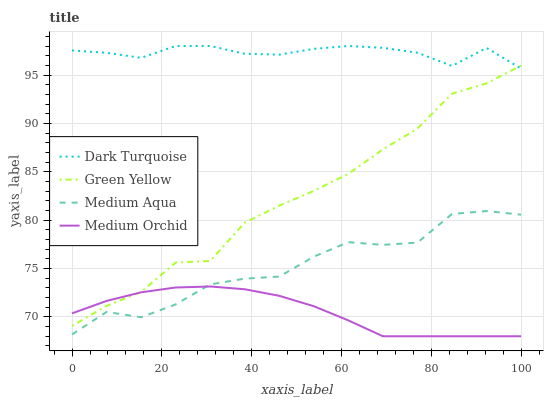Does Medium Orchid have the minimum area under the curve?
Answer yes or no. Yes. Does Dark Turquoise have the maximum area under the curve?
Answer yes or no. Yes. Does Green Yellow have the minimum area under the curve?
Answer yes or no. No. Does Green Yellow have the maximum area under the curve?
Answer yes or no. No. Is Medium Orchid the smoothest?
Answer yes or no. Yes. Is Medium Aqua the roughest?
Answer yes or no. Yes. Is Green Yellow the smoothest?
Answer yes or no. No. Is Green Yellow the roughest?
Answer yes or no. No. Does Medium Orchid have the lowest value?
Answer yes or no. Yes. Does Green Yellow have the lowest value?
Answer yes or no. No. Does Dark Turquoise have the highest value?
Answer yes or no. Yes. Does Green Yellow have the highest value?
Answer yes or no. No. Is Medium Orchid less than Dark Turquoise?
Answer yes or no. Yes. Is Green Yellow greater than Medium Aqua?
Answer yes or no. Yes. Does Green Yellow intersect Dark Turquoise?
Answer yes or no. Yes. Is Green Yellow less than Dark Turquoise?
Answer yes or no. No. Is Green Yellow greater than Dark Turquoise?
Answer yes or no. No. Does Medium Orchid intersect Dark Turquoise?
Answer yes or no. No. 